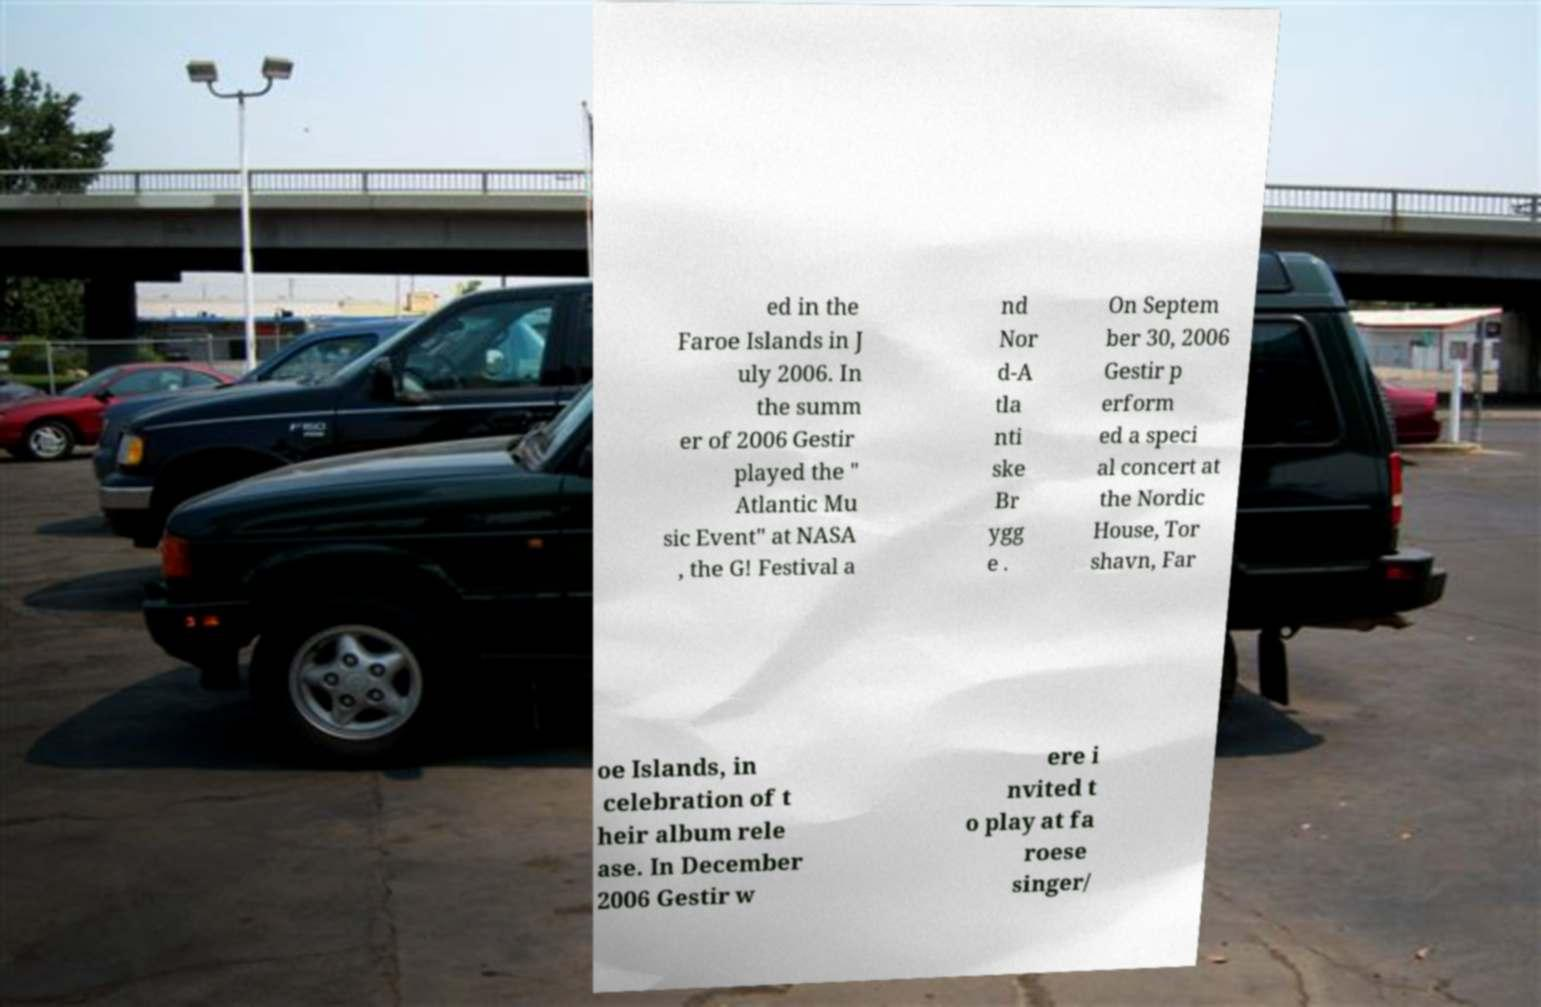Please read and relay the text visible in this image. What does it say? ed in the Faroe Islands in J uly 2006. In the summ er of 2006 Gestir played the " Atlantic Mu sic Event" at NASA , the G! Festival a nd Nor d-A tla nti ske Br ygg e . On Septem ber 30, 2006 Gestir p erform ed a speci al concert at the Nordic House, Tor shavn, Far oe Islands, in celebration of t heir album rele ase. In December 2006 Gestir w ere i nvited t o play at fa roese singer/ 